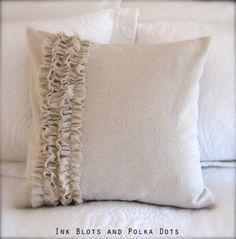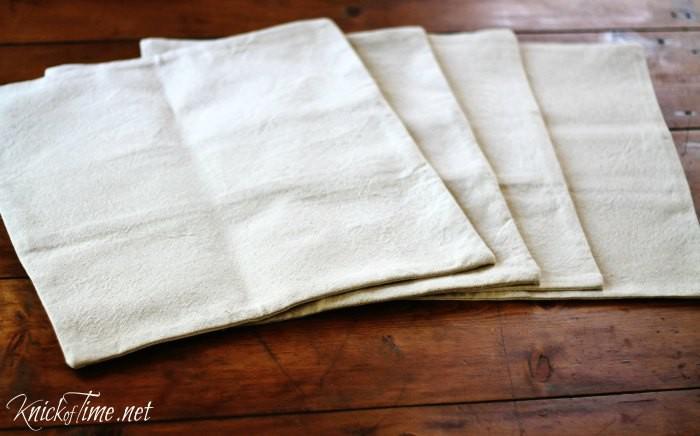The first image is the image on the left, the second image is the image on the right. Analyze the images presented: Is the assertion "There are at least three pillows in one of the images." valid? Answer yes or no. No. The first image is the image on the left, the second image is the image on the right. Evaluate the accuracy of this statement regarding the images: "An image features a square pillow with multiple rows of ruffles across its front.". Is it true? Answer yes or no. Yes. 